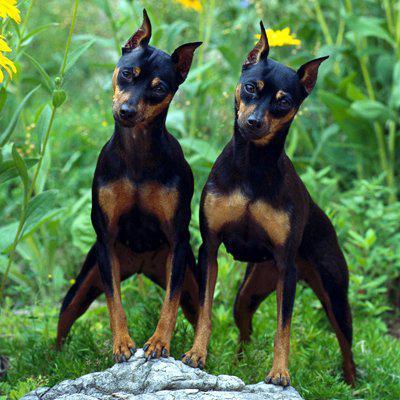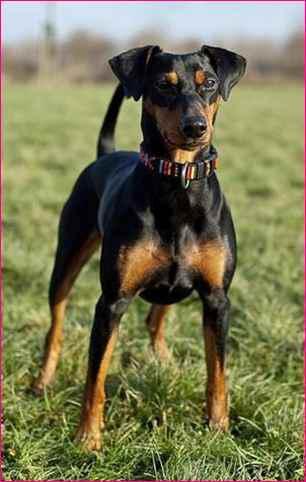The first image is the image on the left, the second image is the image on the right. Given the left and right images, does the statement "there is a doberman wearing a silver chain collar" hold true? Answer yes or no. No. The first image is the image on the left, the second image is the image on the right. For the images shown, is this caption "The left image contains a left-facing dock-tailed dog standing in profile, with a handler behind it, and the right image contains one erect-eared dog wearing a chain collar." true? Answer yes or no. No. 